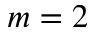<formula> <loc_0><loc_0><loc_500><loc_500>m = 2</formula> 